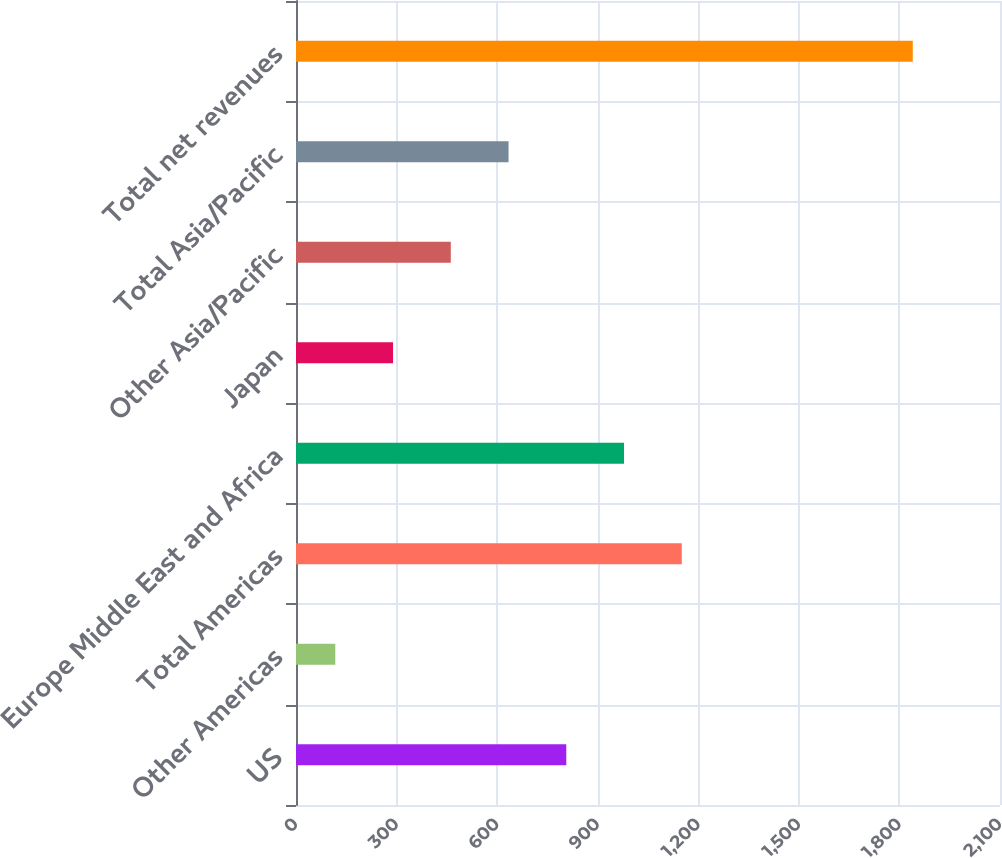Convert chart to OTSL. <chart><loc_0><loc_0><loc_500><loc_500><bar_chart><fcel>US<fcel>Other Americas<fcel>Total Americas<fcel>Europe Middle East and Africa<fcel>Japan<fcel>Other Asia/Pacific<fcel>Total Asia/Pacific<fcel>Total net revenues<nl><fcel>806.24<fcel>117.2<fcel>1150.76<fcel>978.5<fcel>289.46<fcel>461.72<fcel>633.98<fcel>1839.8<nl></chart> 